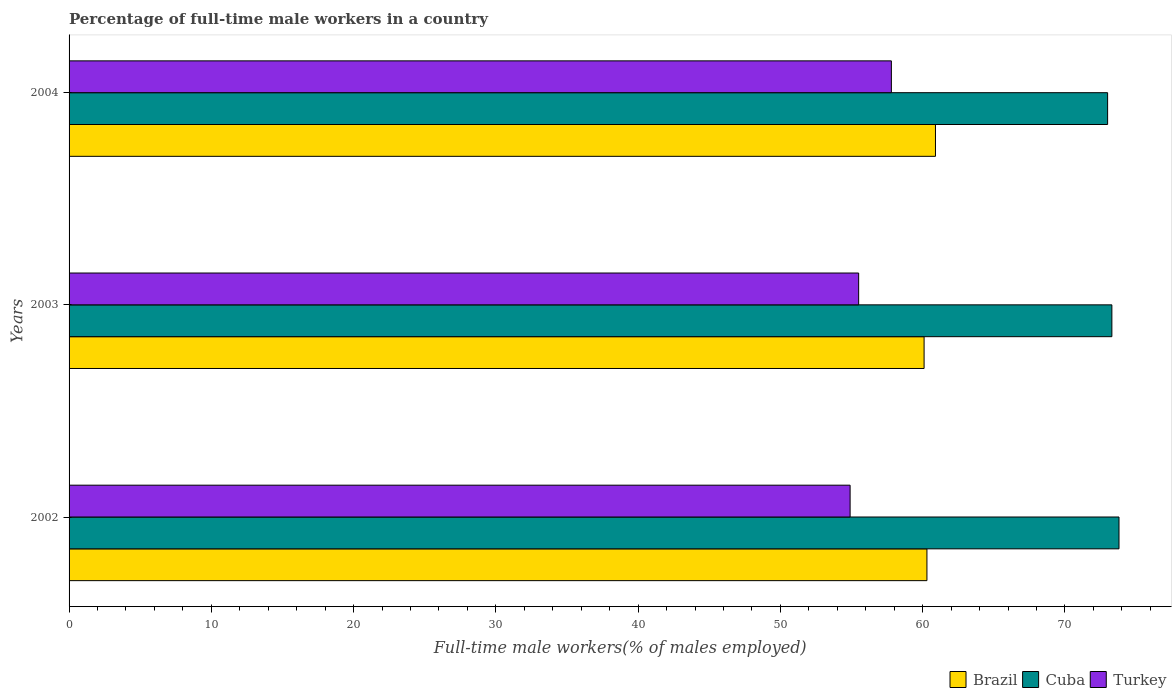Are the number of bars per tick equal to the number of legend labels?
Provide a succinct answer. Yes. Are the number of bars on each tick of the Y-axis equal?
Offer a very short reply. Yes. How many bars are there on the 3rd tick from the top?
Make the answer very short. 3. How many bars are there on the 1st tick from the bottom?
Offer a very short reply. 3. What is the label of the 1st group of bars from the top?
Provide a succinct answer. 2004. In how many cases, is the number of bars for a given year not equal to the number of legend labels?
Keep it short and to the point. 0. What is the percentage of full-time male workers in Brazil in 2003?
Provide a short and direct response. 60.1. Across all years, what is the maximum percentage of full-time male workers in Turkey?
Offer a terse response. 57.8. Across all years, what is the minimum percentage of full-time male workers in Turkey?
Offer a terse response. 54.9. In which year was the percentage of full-time male workers in Turkey maximum?
Offer a terse response. 2004. What is the total percentage of full-time male workers in Cuba in the graph?
Provide a short and direct response. 220.1. What is the difference between the percentage of full-time male workers in Cuba in 2003 and that in 2004?
Offer a very short reply. 0.3. What is the difference between the percentage of full-time male workers in Brazil in 2004 and the percentage of full-time male workers in Cuba in 2002?
Ensure brevity in your answer.  -12.9. What is the average percentage of full-time male workers in Brazil per year?
Provide a succinct answer. 60.43. In the year 2003, what is the difference between the percentage of full-time male workers in Cuba and percentage of full-time male workers in Turkey?
Make the answer very short. 17.8. What is the ratio of the percentage of full-time male workers in Turkey in 2003 to that in 2004?
Your answer should be compact. 0.96. Is the percentage of full-time male workers in Turkey in 2003 less than that in 2004?
Your response must be concise. Yes. Is the difference between the percentage of full-time male workers in Cuba in 2002 and 2003 greater than the difference between the percentage of full-time male workers in Turkey in 2002 and 2003?
Provide a short and direct response. Yes. What is the difference between the highest and the second highest percentage of full-time male workers in Brazil?
Your answer should be very brief. 0.6. What is the difference between the highest and the lowest percentage of full-time male workers in Cuba?
Keep it short and to the point. 0.8. In how many years, is the percentage of full-time male workers in Turkey greater than the average percentage of full-time male workers in Turkey taken over all years?
Your answer should be very brief. 1. Is the sum of the percentage of full-time male workers in Brazil in 2003 and 2004 greater than the maximum percentage of full-time male workers in Turkey across all years?
Ensure brevity in your answer.  Yes. What does the 2nd bar from the top in 2002 represents?
Provide a succinct answer. Cuba. Is it the case that in every year, the sum of the percentage of full-time male workers in Brazil and percentage of full-time male workers in Turkey is greater than the percentage of full-time male workers in Cuba?
Ensure brevity in your answer.  Yes. How many bars are there?
Ensure brevity in your answer.  9. How many years are there in the graph?
Give a very brief answer. 3. Are the values on the major ticks of X-axis written in scientific E-notation?
Your answer should be very brief. No. Does the graph contain any zero values?
Your response must be concise. No. Does the graph contain grids?
Keep it short and to the point. No. Where does the legend appear in the graph?
Provide a short and direct response. Bottom right. How are the legend labels stacked?
Offer a very short reply. Horizontal. What is the title of the graph?
Keep it short and to the point. Percentage of full-time male workers in a country. Does "American Samoa" appear as one of the legend labels in the graph?
Your answer should be compact. No. What is the label or title of the X-axis?
Your response must be concise. Full-time male workers(% of males employed). What is the Full-time male workers(% of males employed) in Brazil in 2002?
Offer a terse response. 60.3. What is the Full-time male workers(% of males employed) in Cuba in 2002?
Your answer should be very brief. 73.8. What is the Full-time male workers(% of males employed) of Turkey in 2002?
Your answer should be compact. 54.9. What is the Full-time male workers(% of males employed) in Brazil in 2003?
Your answer should be very brief. 60.1. What is the Full-time male workers(% of males employed) in Cuba in 2003?
Give a very brief answer. 73.3. What is the Full-time male workers(% of males employed) of Turkey in 2003?
Provide a succinct answer. 55.5. What is the Full-time male workers(% of males employed) in Brazil in 2004?
Ensure brevity in your answer.  60.9. What is the Full-time male workers(% of males employed) in Turkey in 2004?
Keep it short and to the point. 57.8. Across all years, what is the maximum Full-time male workers(% of males employed) in Brazil?
Your response must be concise. 60.9. Across all years, what is the maximum Full-time male workers(% of males employed) of Cuba?
Offer a terse response. 73.8. Across all years, what is the maximum Full-time male workers(% of males employed) of Turkey?
Keep it short and to the point. 57.8. Across all years, what is the minimum Full-time male workers(% of males employed) of Brazil?
Offer a terse response. 60.1. Across all years, what is the minimum Full-time male workers(% of males employed) of Turkey?
Make the answer very short. 54.9. What is the total Full-time male workers(% of males employed) of Brazil in the graph?
Keep it short and to the point. 181.3. What is the total Full-time male workers(% of males employed) of Cuba in the graph?
Provide a succinct answer. 220.1. What is the total Full-time male workers(% of males employed) of Turkey in the graph?
Offer a terse response. 168.2. What is the difference between the Full-time male workers(% of males employed) of Brazil in 2002 and that in 2003?
Your response must be concise. 0.2. What is the difference between the Full-time male workers(% of males employed) in Cuba in 2002 and that in 2003?
Offer a terse response. 0.5. What is the difference between the Full-time male workers(% of males employed) of Turkey in 2002 and that in 2003?
Provide a succinct answer. -0.6. What is the difference between the Full-time male workers(% of males employed) in Cuba in 2002 and that in 2004?
Offer a very short reply. 0.8. What is the difference between the Full-time male workers(% of males employed) of Turkey in 2002 and that in 2004?
Offer a very short reply. -2.9. What is the difference between the Full-time male workers(% of males employed) in Brazil in 2003 and that in 2004?
Provide a succinct answer. -0.8. What is the difference between the Full-time male workers(% of males employed) in Cuba in 2003 and that in 2004?
Offer a terse response. 0.3. What is the difference between the Full-time male workers(% of males employed) of Turkey in 2003 and that in 2004?
Provide a succinct answer. -2.3. What is the difference between the Full-time male workers(% of males employed) in Brazil in 2002 and the Full-time male workers(% of males employed) in Cuba in 2003?
Ensure brevity in your answer.  -13. What is the difference between the Full-time male workers(% of males employed) of Brazil in 2002 and the Full-time male workers(% of males employed) of Turkey in 2003?
Keep it short and to the point. 4.8. What is the difference between the Full-time male workers(% of males employed) of Cuba in 2002 and the Full-time male workers(% of males employed) of Turkey in 2003?
Ensure brevity in your answer.  18.3. What is the difference between the Full-time male workers(% of males employed) in Brazil in 2002 and the Full-time male workers(% of males employed) in Cuba in 2004?
Offer a very short reply. -12.7. What is the difference between the Full-time male workers(% of males employed) in Brazil in 2002 and the Full-time male workers(% of males employed) in Turkey in 2004?
Provide a short and direct response. 2.5. What is the difference between the Full-time male workers(% of males employed) in Brazil in 2003 and the Full-time male workers(% of males employed) in Cuba in 2004?
Offer a terse response. -12.9. What is the difference between the Full-time male workers(% of males employed) in Cuba in 2003 and the Full-time male workers(% of males employed) in Turkey in 2004?
Ensure brevity in your answer.  15.5. What is the average Full-time male workers(% of males employed) of Brazil per year?
Provide a short and direct response. 60.43. What is the average Full-time male workers(% of males employed) in Cuba per year?
Ensure brevity in your answer.  73.37. What is the average Full-time male workers(% of males employed) of Turkey per year?
Provide a succinct answer. 56.07. In the year 2002, what is the difference between the Full-time male workers(% of males employed) in Brazil and Full-time male workers(% of males employed) in Turkey?
Your answer should be very brief. 5.4. In the year 2003, what is the difference between the Full-time male workers(% of males employed) of Brazil and Full-time male workers(% of males employed) of Cuba?
Your answer should be compact. -13.2. In the year 2003, what is the difference between the Full-time male workers(% of males employed) in Brazil and Full-time male workers(% of males employed) in Turkey?
Your response must be concise. 4.6. In the year 2004, what is the difference between the Full-time male workers(% of males employed) in Brazil and Full-time male workers(% of males employed) in Cuba?
Offer a terse response. -12.1. In the year 2004, what is the difference between the Full-time male workers(% of males employed) in Brazil and Full-time male workers(% of males employed) in Turkey?
Your response must be concise. 3.1. In the year 2004, what is the difference between the Full-time male workers(% of males employed) in Cuba and Full-time male workers(% of males employed) in Turkey?
Offer a terse response. 15.2. What is the ratio of the Full-time male workers(% of males employed) in Cuba in 2002 to that in 2003?
Offer a very short reply. 1.01. What is the ratio of the Full-time male workers(% of males employed) of Turkey in 2002 to that in 2003?
Your answer should be compact. 0.99. What is the ratio of the Full-time male workers(% of males employed) of Cuba in 2002 to that in 2004?
Provide a succinct answer. 1.01. What is the ratio of the Full-time male workers(% of males employed) of Turkey in 2002 to that in 2004?
Your answer should be very brief. 0.95. What is the ratio of the Full-time male workers(% of males employed) of Brazil in 2003 to that in 2004?
Ensure brevity in your answer.  0.99. What is the ratio of the Full-time male workers(% of males employed) in Cuba in 2003 to that in 2004?
Ensure brevity in your answer.  1. What is the ratio of the Full-time male workers(% of males employed) of Turkey in 2003 to that in 2004?
Provide a short and direct response. 0.96. What is the difference between the highest and the second highest Full-time male workers(% of males employed) in Turkey?
Provide a short and direct response. 2.3. What is the difference between the highest and the lowest Full-time male workers(% of males employed) in Brazil?
Your answer should be compact. 0.8. What is the difference between the highest and the lowest Full-time male workers(% of males employed) of Turkey?
Provide a short and direct response. 2.9. 